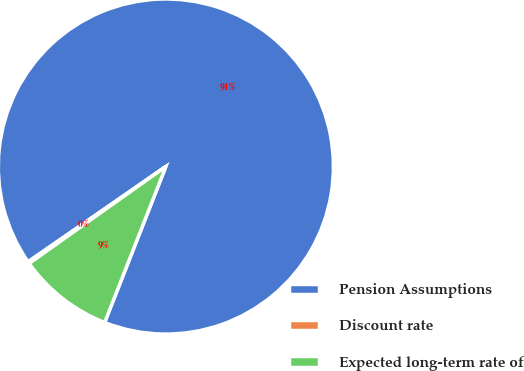Convert chart to OTSL. <chart><loc_0><loc_0><loc_500><loc_500><pie_chart><fcel>Pension Assumptions<fcel>Discount rate<fcel>Expected long-term rate of<nl><fcel>90.57%<fcel>0.19%<fcel>9.23%<nl></chart> 